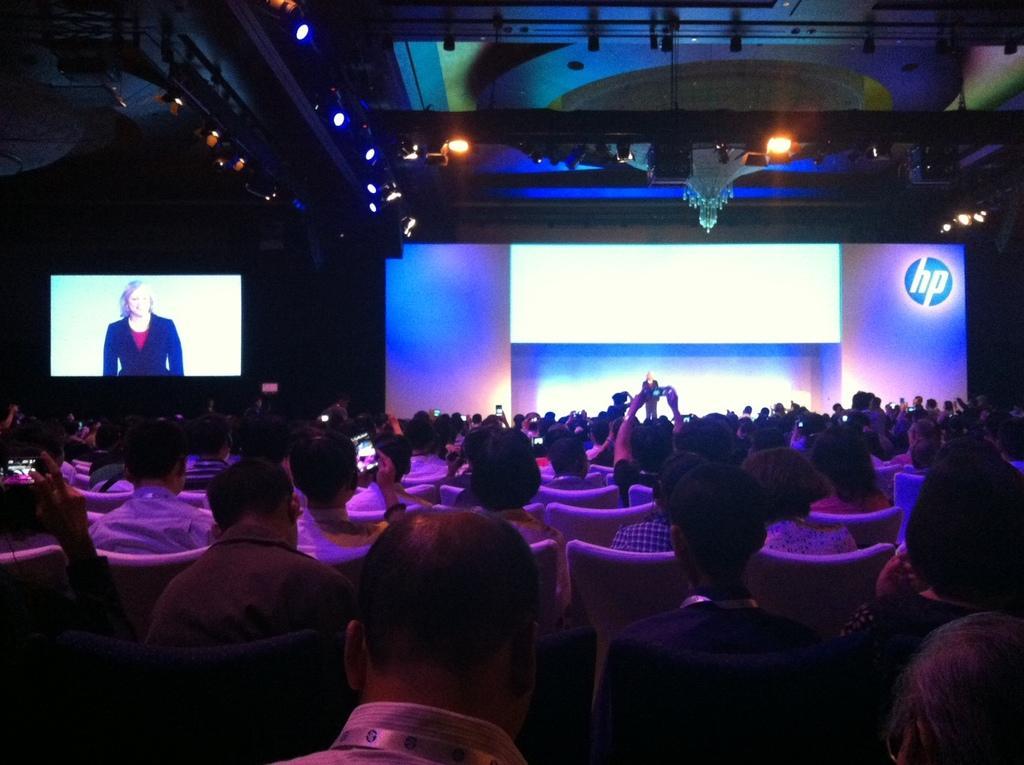Can you describe this image briefly? In this image I can see number of people are sitting on chairs. In the background I can see a person is standing and on left side of this image I can see a screen. On this screen I can see a woman. I can also see few lights and here I can see hp is written. 